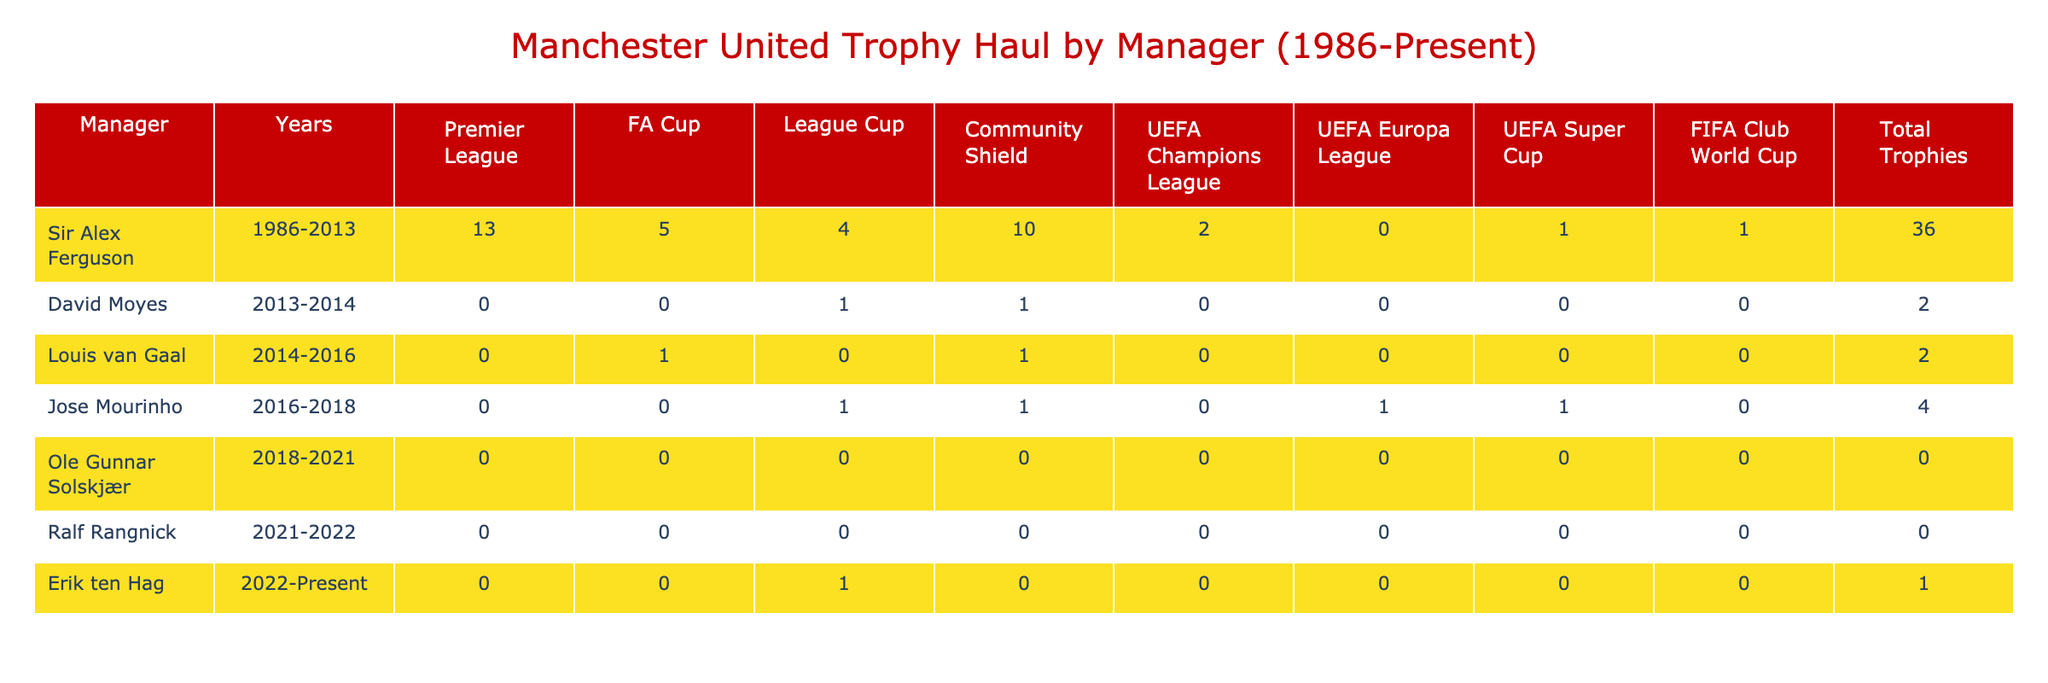What is the total number of trophies won by Sir Alex Ferguson? The table shows that Sir Alex Ferguson won a total of 36 trophies during his tenure from 1986 to 2013.
Answer: 36 How many FA Cups did Jose Mourinho win? According to the table, Jose Mourinho won 0 FA Cups during his time as manager from 2016 to 2018.
Answer: 0 Which manager had the highest total trophy count? The table indicates that Sir Alex Ferguson had the highest total trophy count with 36 trophies, significantly more than any other manager listed.
Answer: Sir Alex Ferguson Did Ole Gunnar Solskjær win any trophies? The table states that Ole Gunnar Solskjær won 0 trophies while he was the manager from 2018 to 2021.
Answer: No What is the difference in the number of trophies won between David Moyes and Louis van Gaal? David Moyes won 2 trophies during the 2013-2014 season, while Louis van Gaal also won 2 trophies from 2014 to 2016. The difference is 2 - 2, which equals 0.
Answer: 0 How many League Cups were won by Manchester United under Sir Alex Ferguson? Referring to the table, Sir Alex Ferguson won 4 League Cups while managing Manchester United.
Answer: 4 What percentage of total trophies won by Jose Mourinho were international trophies? Jose Mourinho won a total of 4 trophies, which includes 1 UEFA Super Cup. To find the percentage, calculate (1/4) * 100 = 25%.
Answer: 25% Which manager won the most Community Shields? Sir Alex Ferguson won the most Community Shields with a total of 10 during his managerial career from 1986 to 2013, as indicated in the table.
Answer: Sir Alex Ferguson How many trophies did Erik ten Hag win by October 2023? According to the table, Erik ten Hag has won only 1 trophy during his time at Manchester United up to October 2023.
Answer: 1 